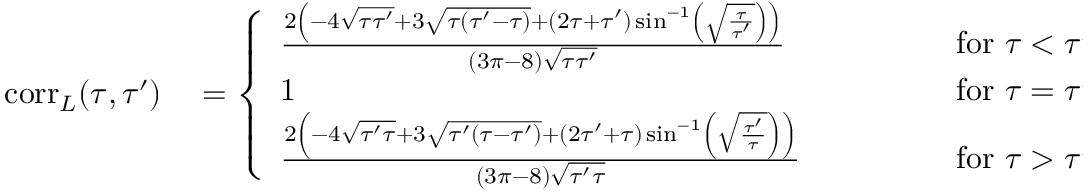Convert formula to latex. <formula><loc_0><loc_0><loc_500><loc_500>\begin{array} { r l } { c o r r _ { L } ( \tau , \tau ^ { \prime } ) } & = \left \{ \begin{array} { l l } { \frac { 2 \left ( - 4 \sqrt { \tau \tau ^ { \prime } } + 3 \sqrt { \tau ( \tau ^ { \prime } - \tau ) } + ( 2 \tau + \tau ^ { \prime } ) \sin ^ { - 1 } \left ( \sqrt { \frac { \tau } { \tau ^ { \prime } } } \right ) \right ) } { ( 3 \pi - 8 ) \sqrt { \tau \tau ^ { \prime } } } \quad \, } & { f o r \ \tau < \tau ^ { \prime } } \\ { 1 \quad q q u a d \, } & { f o r \ \tau = \tau ^ { \prime } } \\ { \frac { 2 \left ( - 4 \sqrt { \tau ^ { \prime } \tau } + 3 \sqrt { \tau ^ { \prime } ( \tau - \tau ^ { \prime } ) } + ( 2 \tau ^ { \prime } + \tau ) \sin ^ { - 1 } \left ( \sqrt { \frac { \tau ^ { \prime } } { \tau } } \right ) \right ) } { ( 3 \pi - 8 ) \sqrt { \tau ^ { \prime } \tau } } \quad } & { f o r \ \tau > \tau ^ { \prime } \ . } \end{array} } \end{array}</formula> 